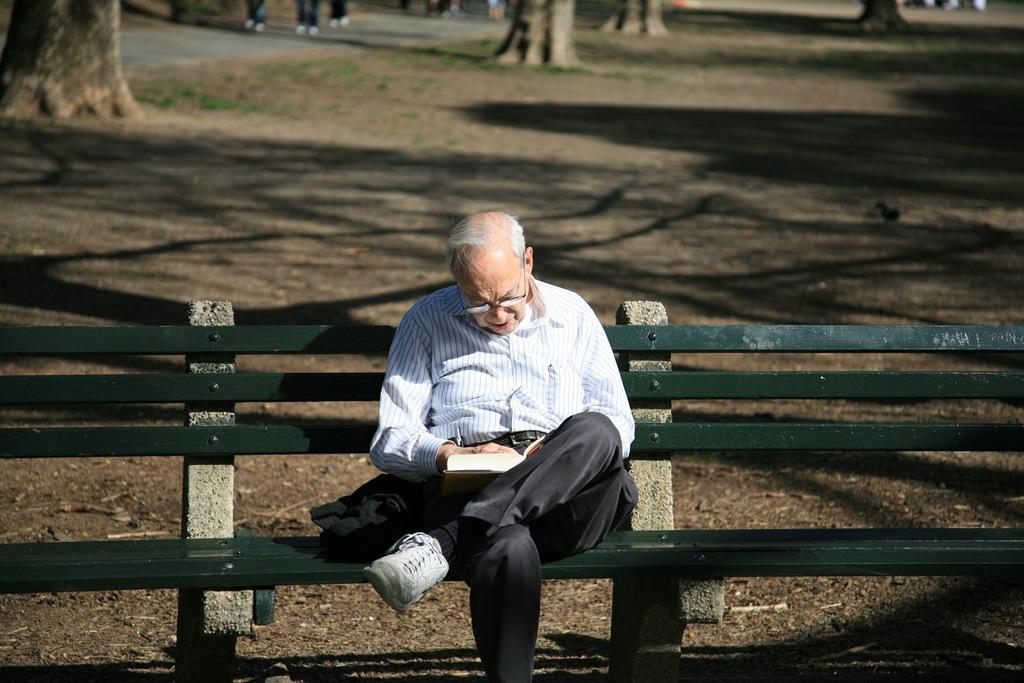How would you summarize this image in a sentence or two? In this picture I can observe an old man sitting on the bench. He is wearing spectacles. In the background there are some trees. 